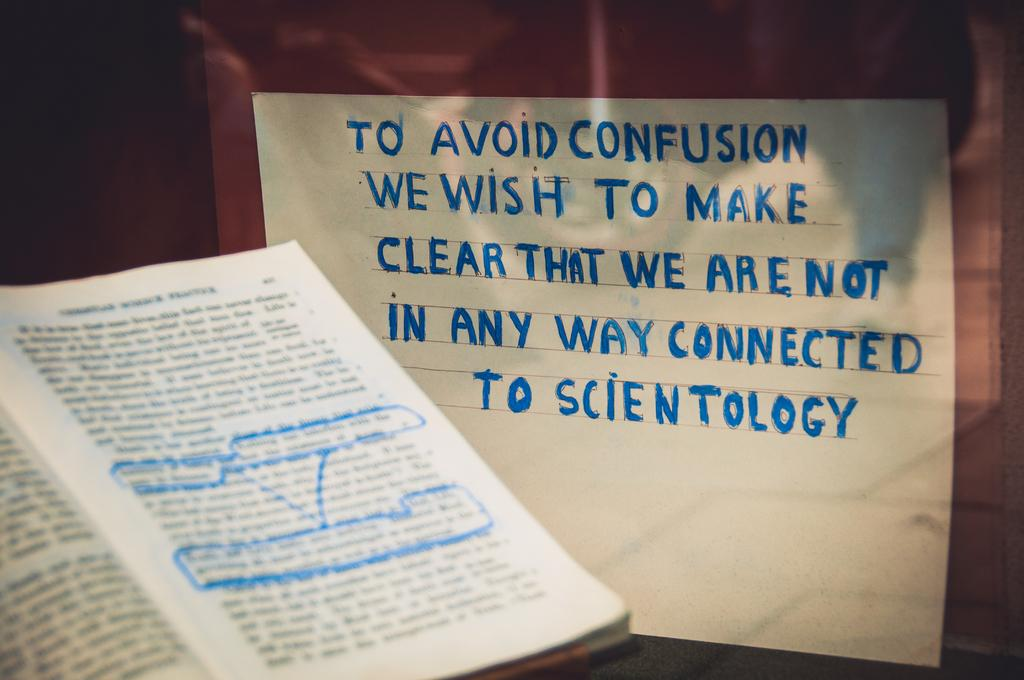<image>
Write a terse but informative summary of the picture. A highlighed book sits on a table next to a sign that says they are not connected to scientology. 